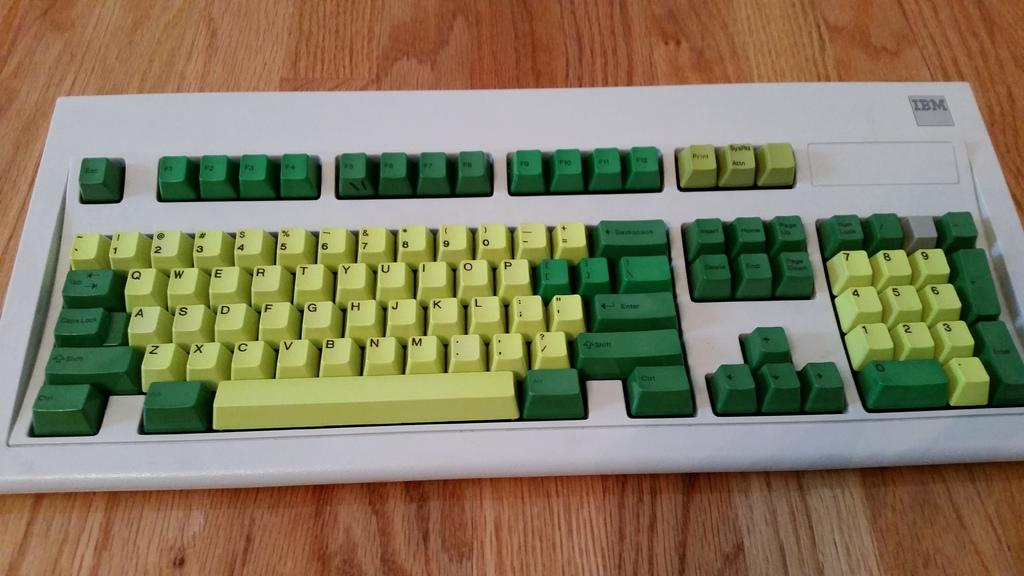Provide a one-sentence caption for the provided image. A yellow and green keyboard has a green enter key. 